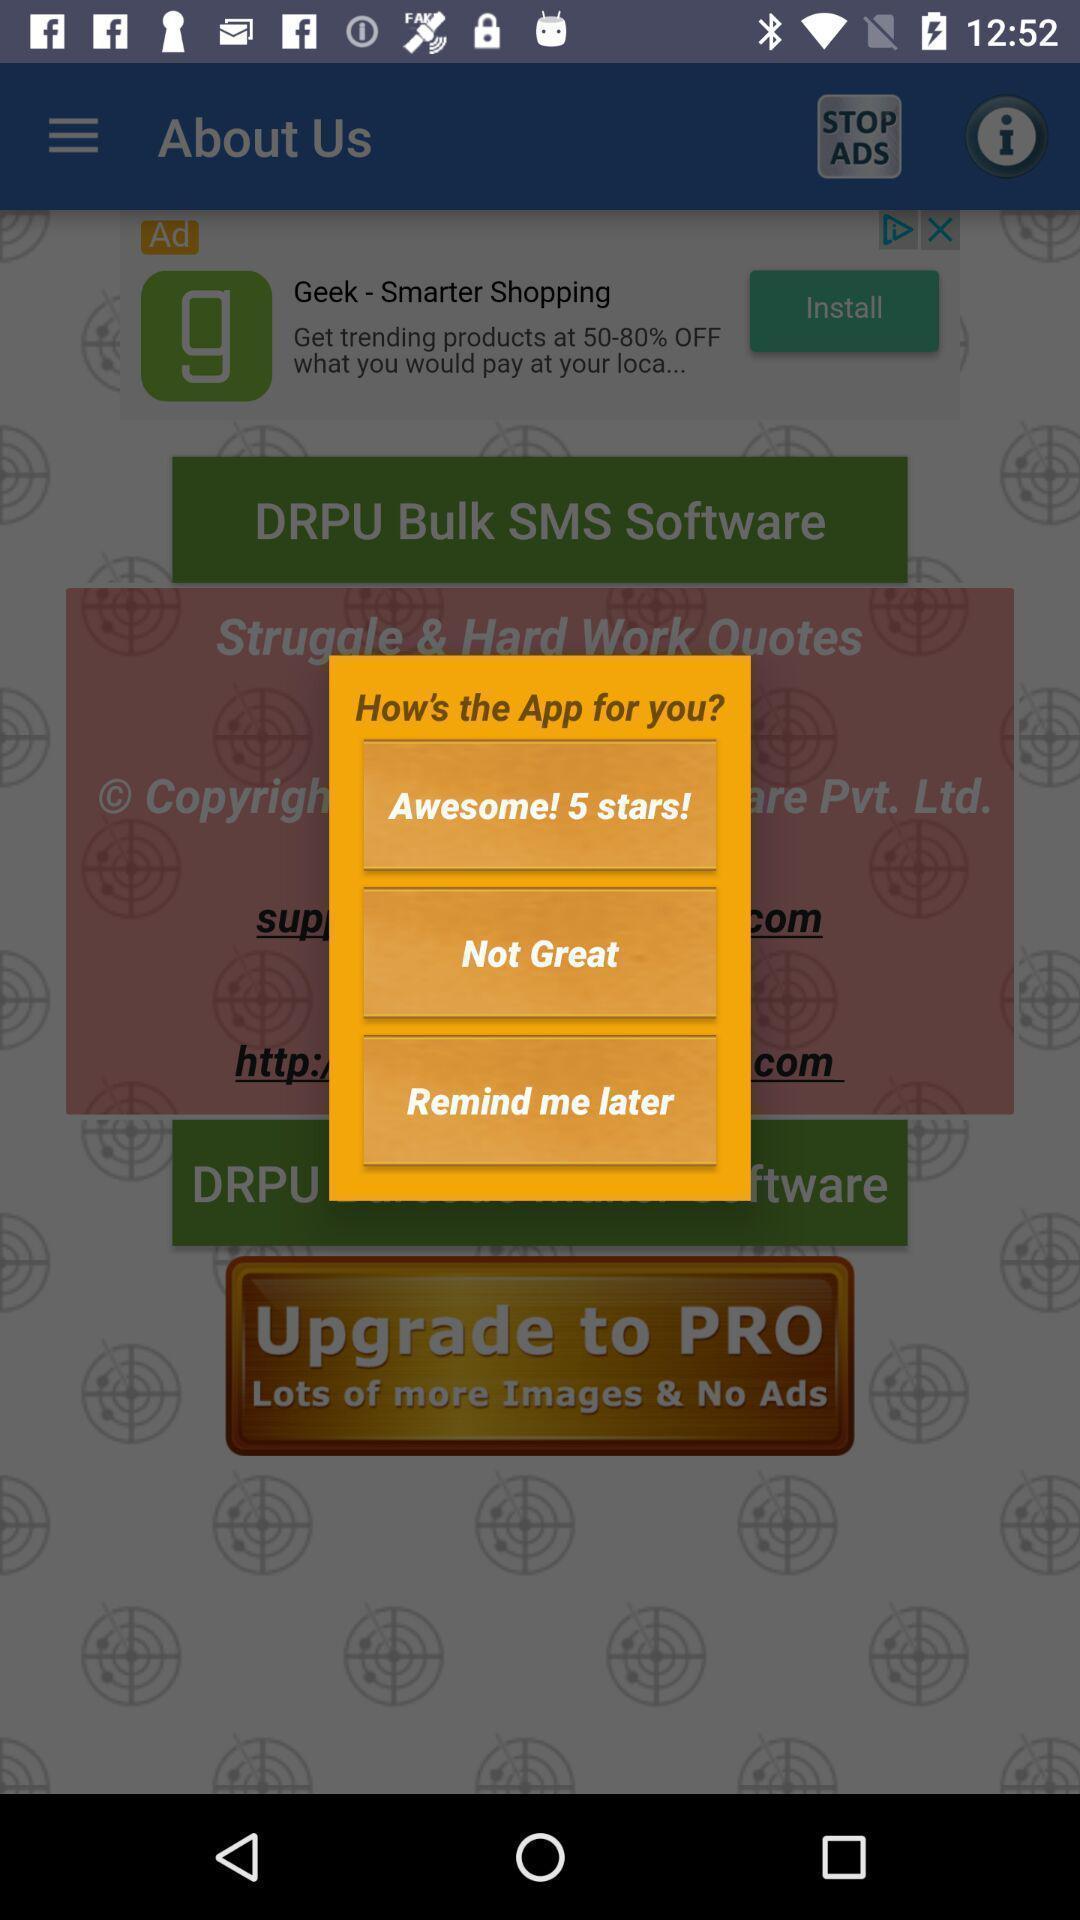Please provide a description for this image. Pop-up showing to rate quotes app. 